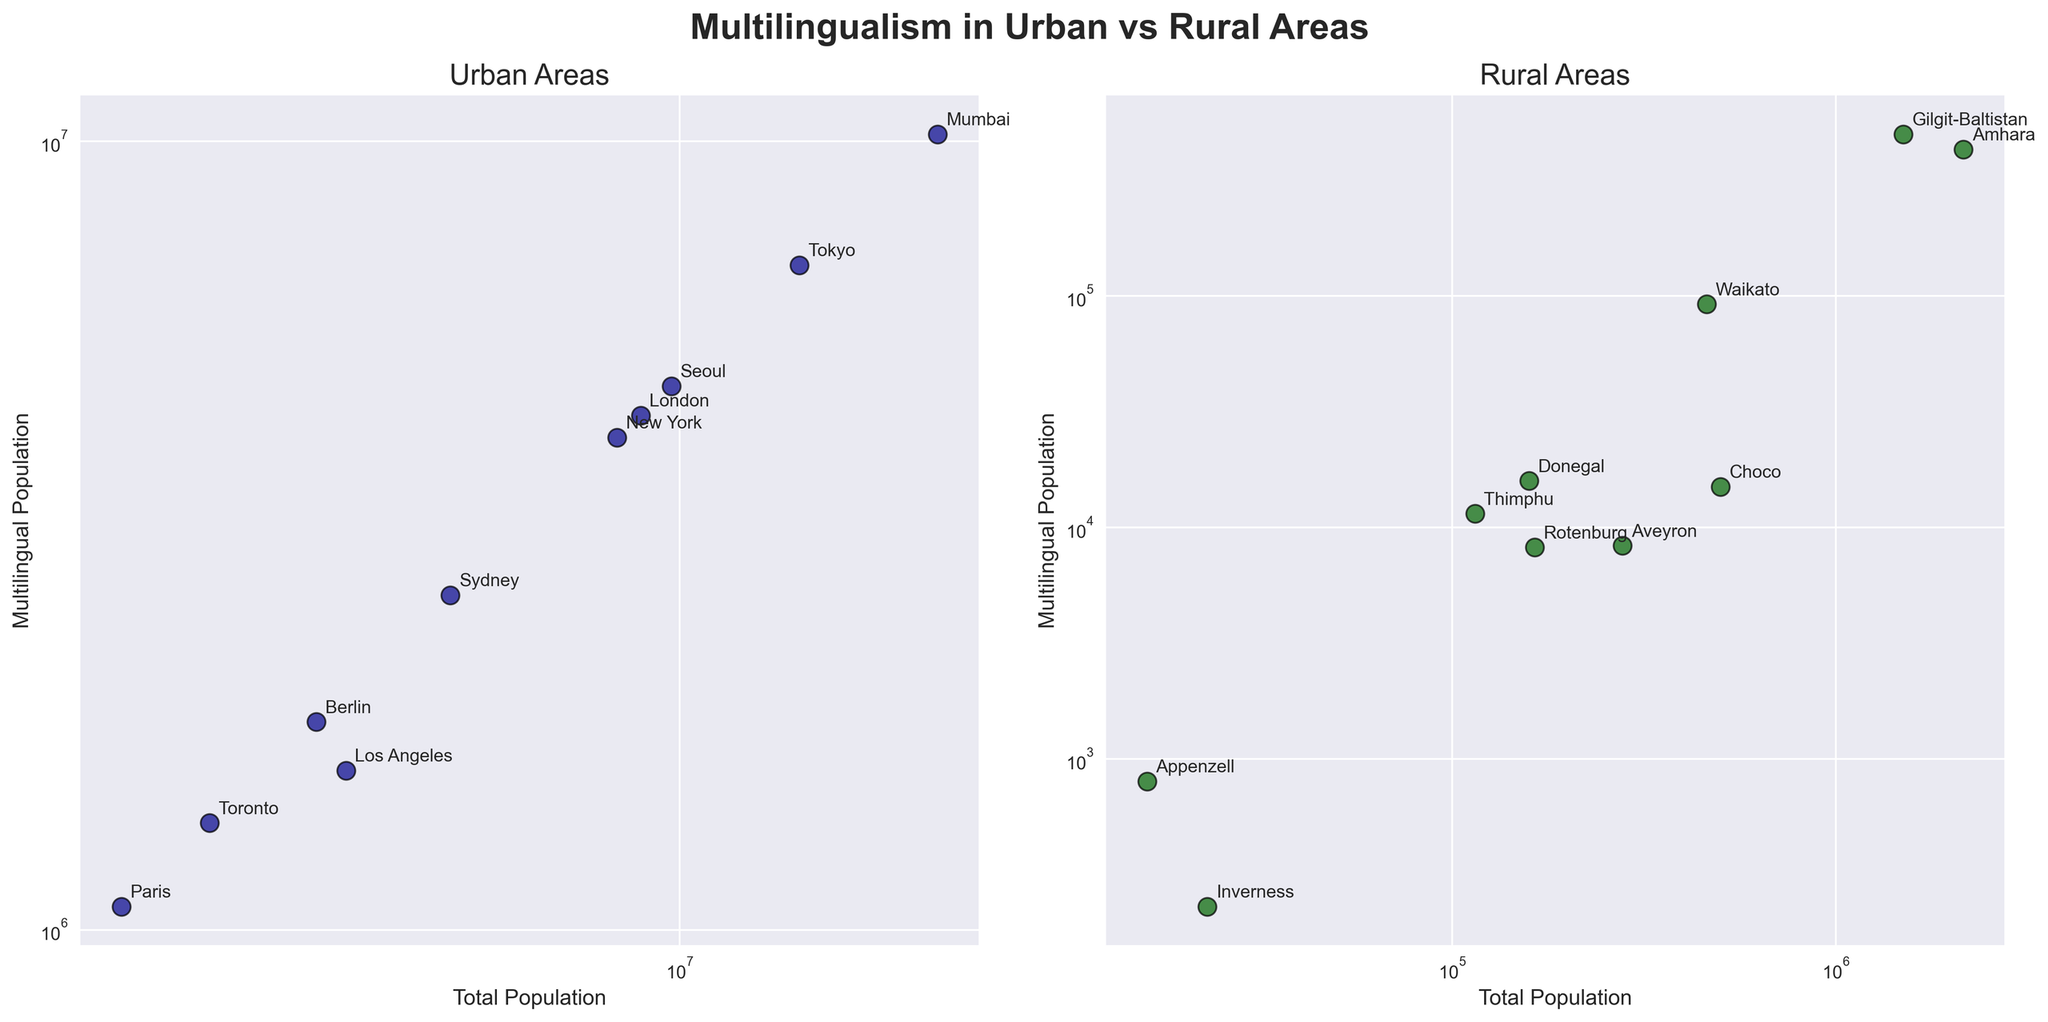What is the title of the figure? The figure's title is usually displayed at the top. For this figure, it is "Multilingualism in Urban vs Rural Areas."
Answer: Multilingualism in Urban vs Rural Areas What are the axis labels for the urban areas plot? Checking the subplot specifically for urban areas, the x-axis is labeled "Total Population" and the y-axis is labeled "Multilingual Population."
Answer: Total Population, Multilingual Population How many urban areas are represented in the figure? The urban subplot contains one data point for each urban area listed in the dataset. Counting the points reveals 10 urban areas.
Answer: 10 Which rural area has the smallest multilingual population? In the rural subplot, among the data points, "Inverness" has the smallest value in the y-axis (Multilingual Population). The label "Inverness" is positioned at the lowest point on the y-axis.
Answer: Inverness Which area, urban or rural, has a higher total population based on the figure? Observing the x-axis values (log scale) for both urban and rural subplots, the urban areas have data points representing higher populations.
Answer: Urban What is the multilingual population percentage in London? In the urban subplot, the total population for London is 8,982,000 and the multilingual population is 4,491,000. The percentage is calculated as (4,491,000 / 8,982,000) * 100.
Answer: 50% Is the multilingual population in rural Thimphu greater than that of rural Aveyron? Checking the rural area subplot, Thimphu has a multilingual population of 11,455, which is greater than Aveyron's 8,341.
Answer: Yes What is the largest multilingual population value on the rural subplot? On the rural subplot, "Amhara" has the highest value on the y-axis (430,000 multilingual population).
Answer: 430,000 Which urban area has the lowest multilingual population, and what is its value? In the urban subplot, "Los Angeles" has the lowest multilingual population value, displayed as the smallest y-axis value among urban data points (1,592,160).
Answer: Los Angeles, 1,592,160 Which plot, urban or rural, has a larger range of multilingual population values? By observing the range of values on the y-axis in both subplots, the urban plot spans a much wider range (from about 1,592,160 to 10,205,500) compared to the rural plot.
Answer: Urban 